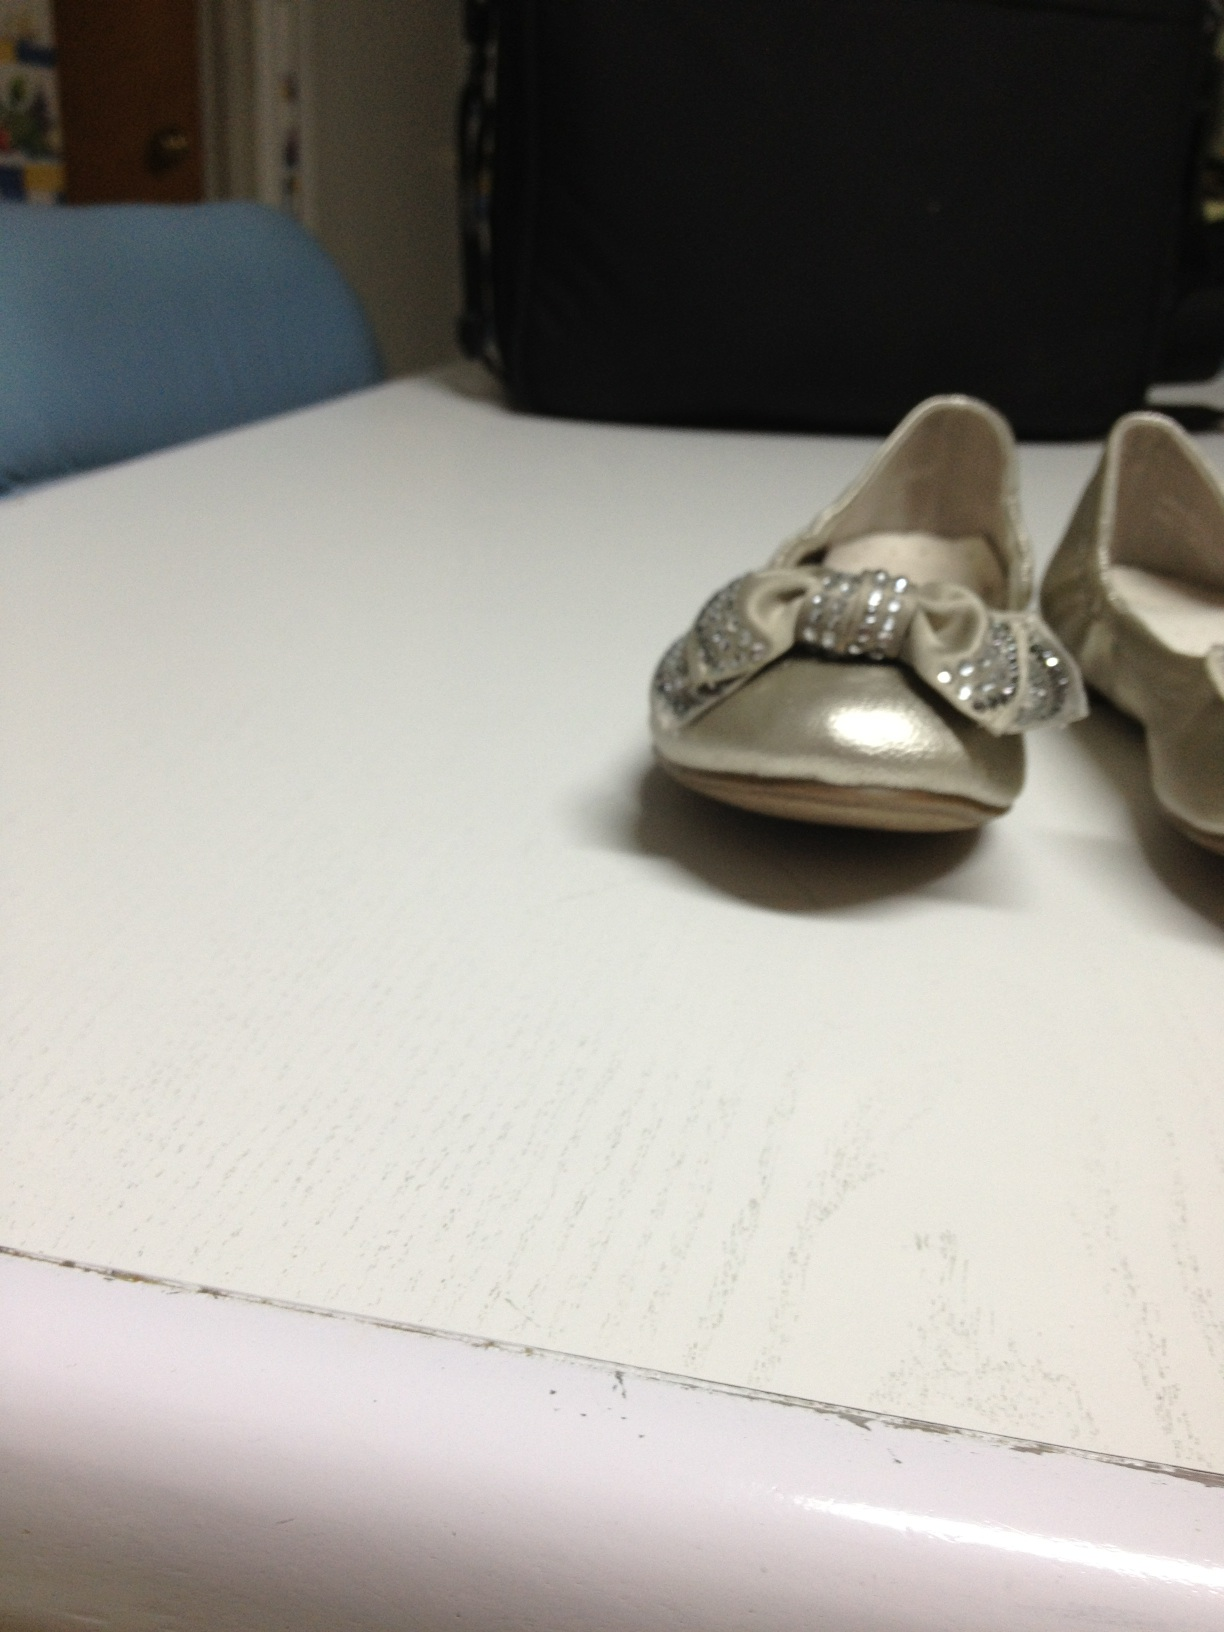What kind of outfit would best complement these shoes for a special occasion? For a special occasion, these elegant silver shoes with sparkling bows would look best paired with a delicate, perhaps pastel-colored dress, adorned with subtle embellishments. A white or light pink dress with lace details would complement the sleek design of the shoes. Accessorize with a matching hairband or bow, and a small, stylish clutch, to complete the charming and festive look. 